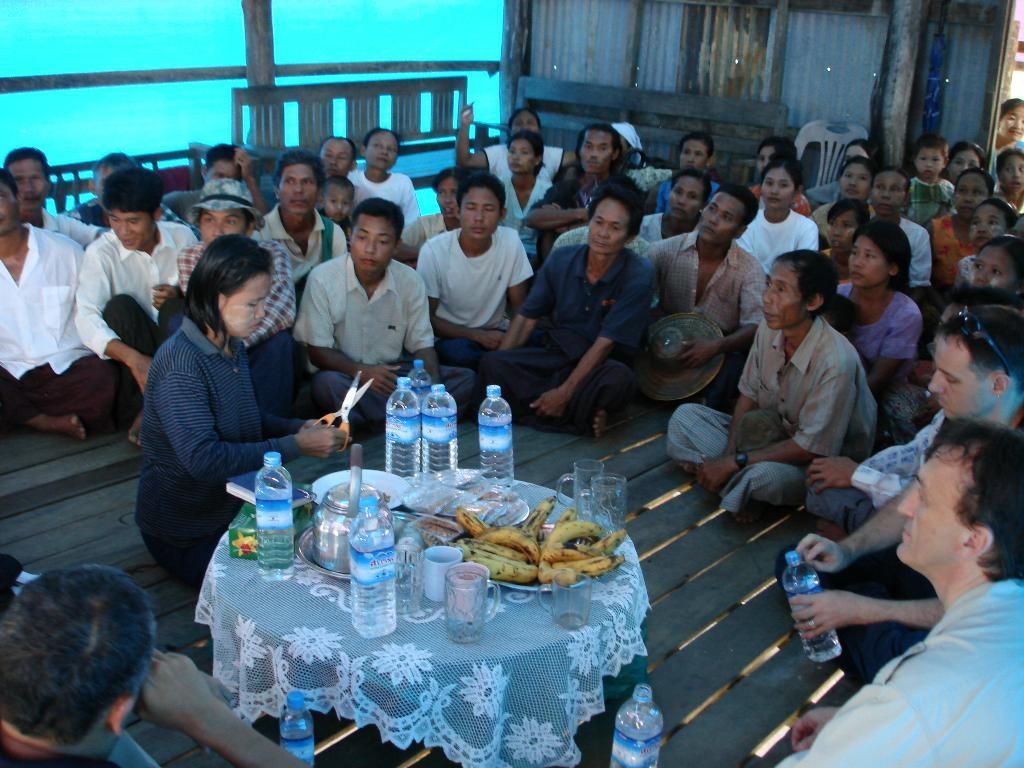What are the people in the image doing? The people in the image are sitting on the floor around a table. What objects can be seen on the table? There is a water bottle, a banana, and a bowl on the table. Can you describe the woman sitting in front of the table? The woman sitting in front of the table is holding scissors in her hand. What type of cherry is being used to cut the fabric in the image? There is no cherry present in the image, and the woman is holding scissors, not a cherry. Is this a family gathering for dinner in the image? The image does not provide enough information to determine if it is a family gathering or a dinner. 